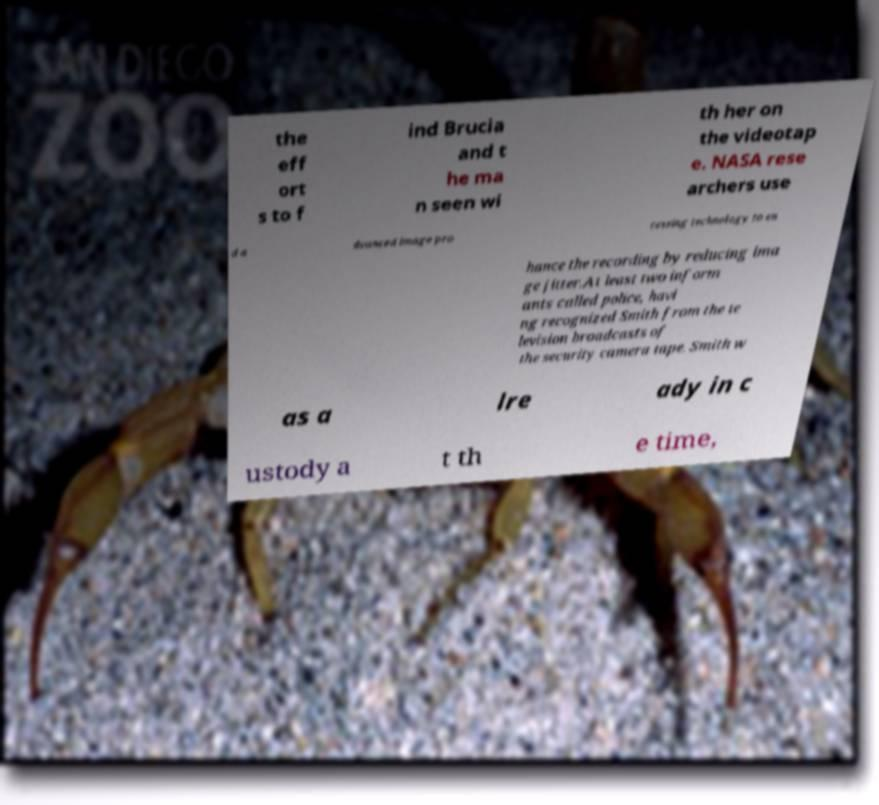Please identify and transcribe the text found in this image. the eff ort s to f ind Brucia and t he ma n seen wi th her on the videotap e. NASA rese archers use d a dvanced image pro cessing technology to en hance the recording by reducing ima ge jitter.At least two inform ants called police, havi ng recognized Smith from the te levision broadcasts of the security camera tape. Smith w as a lre ady in c ustody a t th e time, 